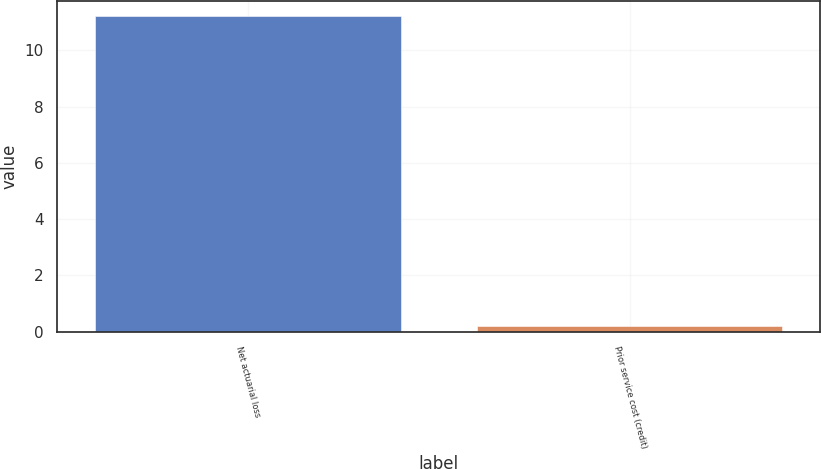<chart> <loc_0><loc_0><loc_500><loc_500><bar_chart><fcel>Net actuarial loss<fcel>Prior service cost (credit)<nl><fcel>11.2<fcel>0.2<nl></chart> 